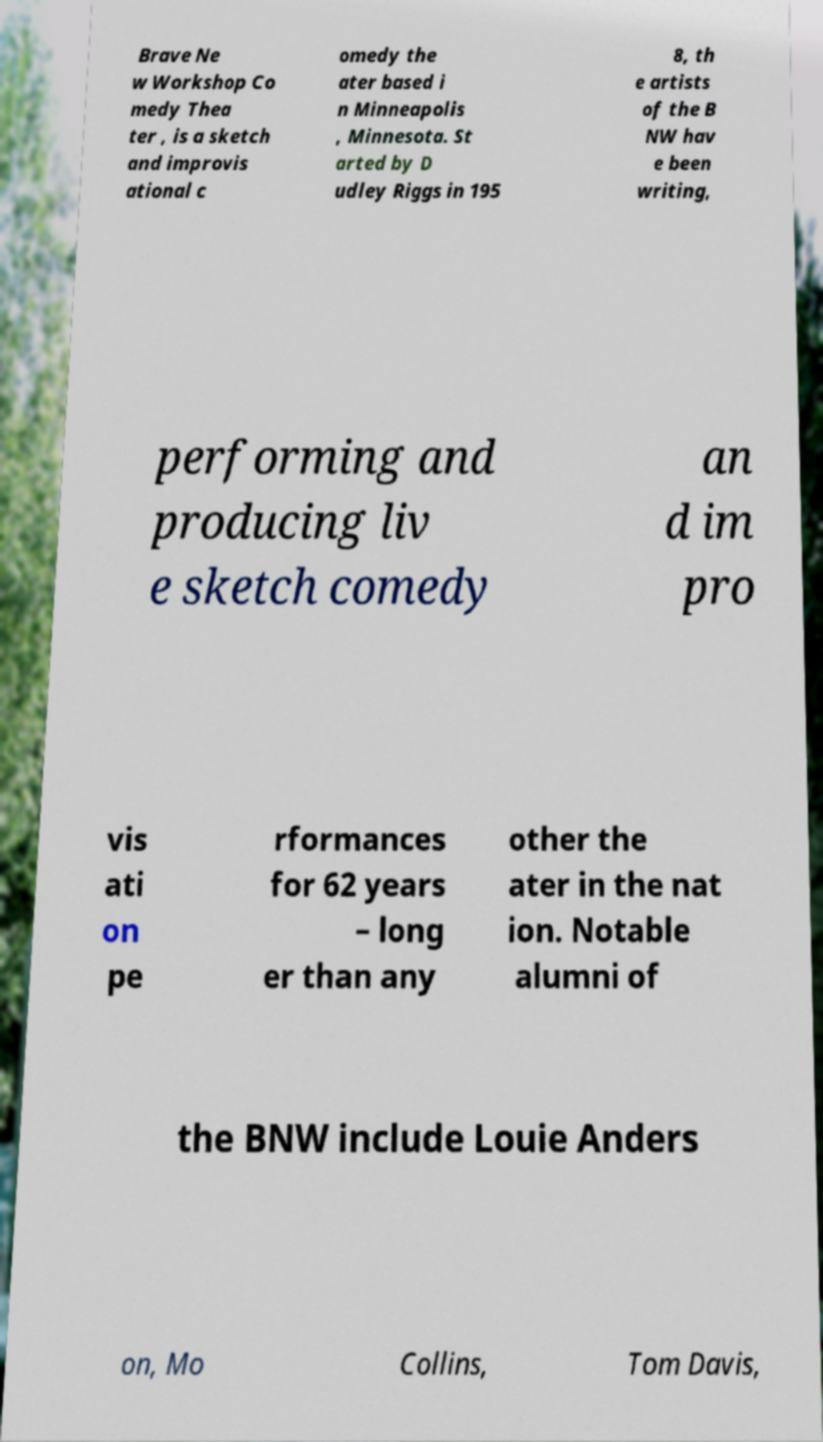What messages or text are displayed in this image? I need them in a readable, typed format. Brave Ne w Workshop Co medy Thea ter , is a sketch and improvis ational c omedy the ater based i n Minneapolis , Minnesota. St arted by D udley Riggs in 195 8, th e artists of the B NW hav e been writing, performing and producing liv e sketch comedy an d im pro vis ati on pe rformances for 62 years – long er than any other the ater in the nat ion. Notable alumni of the BNW include Louie Anders on, Mo Collins, Tom Davis, 